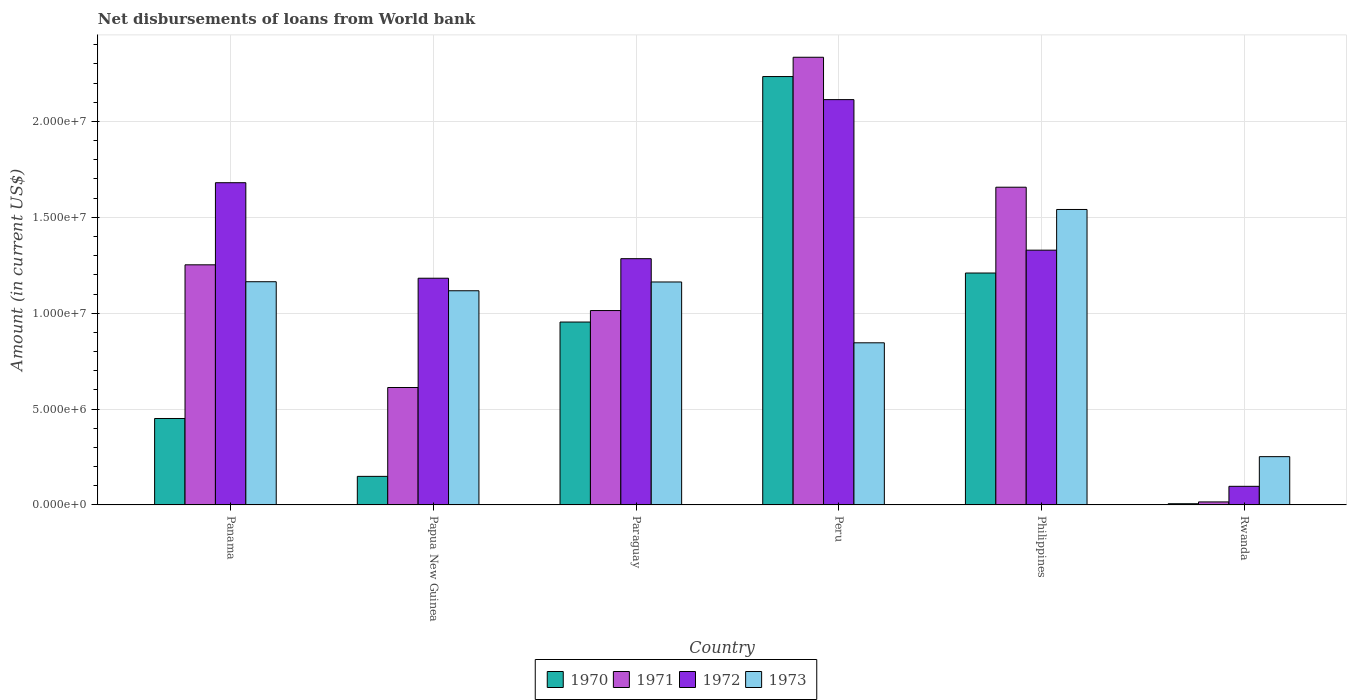How many bars are there on the 4th tick from the left?
Your response must be concise. 4. How many bars are there on the 5th tick from the right?
Give a very brief answer. 4. In how many cases, is the number of bars for a given country not equal to the number of legend labels?
Your response must be concise. 0. What is the amount of loan disbursed from World Bank in 1970 in Peru?
Offer a terse response. 2.23e+07. Across all countries, what is the maximum amount of loan disbursed from World Bank in 1973?
Offer a very short reply. 1.54e+07. Across all countries, what is the minimum amount of loan disbursed from World Bank in 1971?
Provide a succinct answer. 1.57e+05. In which country was the amount of loan disbursed from World Bank in 1970 minimum?
Keep it short and to the point. Rwanda. What is the total amount of loan disbursed from World Bank in 1970 in the graph?
Your answer should be very brief. 5.00e+07. What is the difference between the amount of loan disbursed from World Bank in 1970 in Papua New Guinea and that in Rwanda?
Your response must be concise. 1.43e+06. What is the difference between the amount of loan disbursed from World Bank in 1973 in Rwanda and the amount of loan disbursed from World Bank in 1971 in Peru?
Give a very brief answer. -2.08e+07. What is the average amount of loan disbursed from World Bank in 1972 per country?
Make the answer very short. 1.28e+07. What is the difference between the amount of loan disbursed from World Bank of/in 1973 and amount of loan disbursed from World Bank of/in 1970 in Philippines?
Make the answer very short. 3.31e+06. In how many countries, is the amount of loan disbursed from World Bank in 1970 greater than 12000000 US$?
Your answer should be compact. 2. What is the ratio of the amount of loan disbursed from World Bank in 1973 in Panama to that in Paraguay?
Your answer should be very brief. 1. Is the amount of loan disbursed from World Bank in 1972 in Panama less than that in Rwanda?
Provide a short and direct response. No. What is the difference between the highest and the second highest amount of loan disbursed from World Bank in 1973?
Offer a terse response. 3.78e+06. What is the difference between the highest and the lowest amount of loan disbursed from World Bank in 1972?
Make the answer very short. 2.02e+07. In how many countries, is the amount of loan disbursed from World Bank in 1970 greater than the average amount of loan disbursed from World Bank in 1970 taken over all countries?
Keep it short and to the point. 3. Is it the case that in every country, the sum of the amount of loan disbursed from World Bank in 1973 and amount of loan disbursed from World Bank in 1970 is greater than the sum of amount of loan disbursed from World Bank in 1971 and amount of loan disbursed from World Bank in 1972?
Offer a very short reply. Yes. What does the 1st bar from the left in Philippines represents?
Ensure brevity in your answer.  1970. What does the 2nd bar from the right in Rwanda represents?
Give a very brief answer. 1972. Is it the case that in every country, the sum of the amount of loan disbursed from World Bank in 1972 and amount of loan disbursed from World Bank in 1971 is greater than the amount of loan disbursed from World Bank in 1970?
Give a very brief answer. Yes. How many bars are there?
Your answer should be very brief. 24. Are all the bars in the graph horizontal?
Give a very brief answer. No. How many countries are there in the graph?
Your answer should be very brief. 6. What is the difference between two consecutive major ticks on the Y-axis?
Provide a succinct answer. 5.00e+06. Are the values on the major ticks of Y-axis written in scientific E-notation?
Offer a very short reply. Yes. Does the graph contain grids?
Give a very brief answer. Yes. Where does the legend appear in the graph?
Ensure brevity in your answer.  Bottom center. What is the title of the graph?
Make the answer very short. Net disbursements of loans from World bank. What is the Amount (in current US$) of 1970 in Panama?
Offer a terse response. 4.51e+06. What is the Amount (in current US$) in 1971 in Panama?
Provide a succinct answer. 1.25e+07. What is the Amount (in current US$) in 1972 in Panama?
Make the answer very short. 1.68e+07. What is the Amount (in current US$) in 1973 in Panama?
Offer a very short reply. 1.16e+07. What is the Amount (in current US$) in 1970 in Papua New Guinea?
Provide a short and direct response. 1.49e+06. What is the Amount (in current US$) of 1971 in Papua New Guinea?
Make the answer very short. 6.12e+06. What is the Amount (in current US$) in 1972 in Papua New Guinea?
Offer a terse response. 1.18e+07. What is the Amount (in current US$) of 1973 in Papua New Guinea?
Provide a succinct answer. 1.12e+07. What is the Amount (in current US$) of 1970 in Paraguay?
Ensure brevity in your answer.  9.54e+06. What is the Amount (in current US$) in 1971 in Paraguay?
Your answer should be compact. 1.01e+07. What is the Amount (in current US$) of 1972 in Paraguay?
Provide a short and direct response. 1.28e+07. What is the Amount (in current US$) in 1973 in Paraguay?
Your response must be concise. 1.16e+07. What is the Amount (in current US$) in 1970 in Peru?
Make the answer very short. 2.23e+07. What is the Amount (in current US$) of 1971 in Peru?
Give a very brief answer. 2.33e+07. What is the Amount (in current US$) in 1972 in Peru?
Ensure brevity in your answer.  2.11e+07. What is the Amount (in current US$) of 1973 in Peru?
Keep it short and to the point. 8.46e+06. What is the Amount (in current US$) of 1970 in Philippines?
Your answer should be very brief. 1.21e+07. What is the Amount (in current US$) in 1971 in Philippines?
Your answer should be compact. 1.66e+07. What is the Amount (in current US$) in 1972 in Philippines?
Provide a short and direct response. 1.33e+07. What is the Amount (in current US$) of 1973 in Philippines?
Your response must be concise. 1.54e+07. What is the Amount (in current US$) of 1970 in Rwanda?
Offer a terse response. 6.30e+04. What is the Amount (in current US$) of 1971 in Rwanda?
Provide a short and direct response. 1.57e+05. What is the Amount (in current US$) of 1972 in Rwanda?
Provide a succinct answer. 9.71e+05. What is the Amount (in current US$) in 1973 in Rwanda?
Ensure brevity in your answer.  2.52e+06. Across all countries, what is the maximum Amount (in current US$) of 1970?
Provide a succinct answer. 2.23e+07. Across all countries, what is the maximum Amount (in current US$) in 1971?
Your answer should be compact. 2.33e+07. Across all countries, what is the maximum Amount (in current US$) of 1972?
Make the answer very short. 2.11e+07. Across all countries, what is the maximum Amount (in current US$) in 1973?
Keep it short and to the point. 1.54e+07. Across all countries, what is the minimum Amount (in current US$) in 1970?
Give a very brief answer. 6.30e+04. Across all countries, what is the minimum Amount (in current US$) in 1971?
Provide a short and direct response. 1.57e+05. Across all countries, what is the minimum Amount (in current US$) in 1972?
Give a very brief answer. 9.71e+05. Across all countries, what is the minimum Amount (in current US$) of 1973?
Provide a succinct answer. 2.52e+06. What is the total Amount (in current US$) in 1970 in the graph?
Provide a short and direct response. 5.00e+07. What is the total Amount (in current US$) of 1971 in the graph?
Your answer should be compact. 6.89e+07. What is the total Amount (in current US$) of 1972 in the graph?
Provide a short and direct response. 7.69e+07. What is the total Amount (in current US$) of 1973 in the graph?
Keep it short and to the point. 6.08e+07. What is the difference between the Amount (in current US$) of 1970 in Panama and that in Papua New Guinea?
Offer a terse response. 3.02e+06. What is the difference between the Amount (in current US$) of 1971 in Panama and that in Papua New Guinea?
Keep it short and to the point. 6.40e+06. What is the difference between the Amount (in current US$) in 1972 in Panama and that in Papua New Guinea?
Your response must be concise. 4.98e+06. What is the difference between the Amount (in current US$) in 1973 in Panama and that in Papua New Guinea?
Provide a succinct answer. 4.71e+05. What is the difference between the Amount (in current US$) of 1970 in Panama and that in Paraguay?
Your response must be concise. -5.03e+06. What is the difference between the Amount (in current US$) in 1971 in Panama and that in Paraguay?
Offer a very short reply. 2.38e+06. What is the difference between the Amount (in current US$) of 1972 in Panama and that in Paraguay?
Offer a terse response. 3.96e+06. What is the difference between the Amount (in current US$) in 1973 in Panama and that in Paraguay?
Give a very brief answer. 1.30e+04. What is the difference between the Amount (in current US$) of 1970 in Panama and that in Peru?
Give a very brief answer. -1.78e+07. What is the difference between the Amount (in current US$) of 1971 in Panama and that in Peru?
Ensure brevity in your answer.  -1.08e+07. What is the difference between the Amount (in current US$) in 1972 in Panama and that in Peru?
Your answer should be compact. -4.33e+06. What is the difference between the Amount (in current US$) in 1973 in Panama and that in Peru?
Your response must be concise. 3.18e+06. What is the difference between the Amount (in current US$) of 1970 in Panama and that in Philippines?
Offer a very short reply. -7.59e+06. What is the difference between the Amount (in current US$) in 1971 in Panama and that in Philippines?
Keep it short and to the point. -4.05e+06. What is the difference between the Amount (in current US$) in 1972 in Panama and that in Philippines?
Give a very brief answer. 3.52e+06. What is the difference between the Amount (in current US$) of 1973 in Panama and that in Philippines?
Keep it short and to the point. -3.77e+06. What is the difference between the Amount (in current US$) in 1970 in Panama and that in Rwanda?
Ensure brevity in your answer.  4.44e+06. What is the difference between the Amount (in current US$) of 1971 in Panama and that in Rwanda?
Ensure brevity in your answer.  1.24e+07. What is the difference between the Amount (in current US$) of 1972 in Panama and that in Rwanda?
Ensure brevity in your answer.  1.58e+07. What is the difference between the Amount (in current US$) in 1973 in Panama and that in Rwanda?
Keep it short and to the point. 9.12e+06. What is the difference between the Amount (in current US$) in 1970 in Papua New Guinea and that in Paraguay?
Keep it short and to the point. -8.05e+06. What is the difference between the Amount (in current US$) of 1971 in Papua New Guinea and that in Paraguay?
Offer a very short reply. -4.01e+06. What is the difference between the Amount (in current US$) of 1972 in Papua New Guinea and that in Paraguay?
Your response must be concise. -1.02e+06. What is the difference between the Amount (in current US$) of 1973 in Papua New Guinea and that in Paraguay?
Your response must be concise. -4.58e+05. What is the difference between the Amount (in current US$) in 1970 in Papua New Guinea and that in Peru?
Your answer should be compact. -2.08e+07. What is the difference between the Amount (in current US$) in 1971 in Papua New Guinea and that in Peru?
Offer a very short reply. -1.72e+07. What is the difference between the Amount (in current US$) in 1972 in Papua New Guinea and that in Peru?
Provide a succinct answer. -9.31e+06. What is the difference between the Amount (in current US$) of 1973 in Papua New Guinea and that in Peru?
Offer a terse response. 2.71e+06. What is the difference between the Amount (in current US$) in 1970 in Papua New Guinea and that in Philippines?
Provide a short and direct response. -1.06e+07. What is the difference between the Amount (in current US$) in 1971 in Papua New Guinea and that in Philippines?
Make the answer very short. -1.04e+07. What is the difference between the Amount (in current US$) of 1972 in Papua New Guinea and that in Philippines?
Keep it short and to the point. -1.46e+06. What is the difference between the Amount (in current US$) in 1973 in Papua New Guinea and that in Philippines?
Your answer should be very brief. -4.24e+06. What is the difference between the Amount (in current US$) in 1970 in Papua New Guinea and that in Rwanda?
Provide a short and direct response. 1.43e+06. What is the difference between the Amount (in current US$) in 1971 in Papua New Guinea and that in Rwanda?
Offer a very short reply. 5.97e+06. What is the difference between the Amount (in current US$) of 1972 in Papua New Guinea and that in Rwanda?
Keep it short and to the point. 1.09e+07. What is the difference between the Amount (in current US$) in 1973 in Papua New Guinea and that in Rwanda?
Give a very brief answer. 8.65e+06. What is the difference between the Amount (in current US$) in 1970 in Paraguay and that in Peru?
Provide a succinct answer. -1.28e+07. What is the difference between the Amount (in current US$) in 1971 in Paraguay and that in Peru?
Provide a succinct answer. -1.32e+07. What is the difference between the Amount (in current US$) of 1972 in Paraguay and that in Peru?
Offer a very short reply. -8.30e+06. What is the difference between the Amount (in current US$) in 1973 in Paraguay and that in Peru?
Your answer should be compact. 3.17e+06. What is the difference between the Amount (in current US$) of 1970 in Paraguay and that in Philippines?
Your response must be concise. -2.56e+06. What is the difference between the Amount (in current US$) of 1971 in Paraguay and that in Philippines?
Ensure brevity in your answer.  -6.43e+06. What is the difference between the Amount (in current US$) of 1972 in Paraguay and that in Philippines?
Your response must be concise. -4.44e+05. What is the difference between the Amount (in current US$) of 1973 in Paraguay and that in Philippines?
Offer a very short reply. -3.78e+06. What is the difference between the Amount (in current US$) of 1970 in Paraguay and that in Rwanda?
Provide a succinct answer. 9.48e+06. What is the difference between the Amount (in current US$) of 1971 in Paraguay and that in Rwanda?
Make the answer very short. 9.98e+06. What is the difference between the Amount (in current US$) of 1972 in Paraguay and that in Rwanda?
Ensure brevity in your answer.  1.19e+07. What is the difference between the Amount (in current US$) in 1973 in Paraguay and that in Rwanda?
Offer a terse response. 9.11e+06. What is the difference between the Amount (in current US$) of 1970 in Peru and that in Philippines?
Your answer should be very brief. 1.02e+07. What is the difference between the Amount (in current US$) of 1971 in Peru and that in Philippines?
Give a very brief answer. 6.78e+06. What is the difference between the Amount (in current US$) in 1972 in Peru and that in Philippines?
Give a very brief answer. 7.85e+06. What is the difference between the Amount (in current US$) in 1973 in Peru and that in Philippines?
Offer a very short reply. -6.95e+06. What is the difference between the Amount (in current US$) of 1970 in Peru and that in Rwanda?
Offer a terse response. 2.23e+07. What is the difference between the Amount (in current US$) of 1971 in Peru and that in Rwanda?
Give a very brief answer. 2.32e+07. What is the difference between the Amount (in current US$) in 1972 in Peru and that in Rwanda?
Make the answer very short. 2.02e+07. What is the difference between the Amount (in current US$) of 1973 in Peru and that in Rwanda?
Ensure brevity in your answer.  5.94e+06. What is the difference between the Amount (in current US$) in 1970 in Philippines and that in Rwanda?
Ensure brevity in your answer.  1.20e+07. What is the difference between the Amount (in current US$) in 1971 in Philippines and that in Rwanda?
Offer a terse response. 1.64e+07. What is the difference between the Amount (in current US$) of 1972 in Philippines and that in Rwanda?
Your answer should be very brief. 1.23e+07. What is the difference between the Amount (in current US$) of 1973 in Philippines and that in Rwanda?
Ensure brevity in your answer.  1.29e+07. What is the difference between the Amount (in current US$) of 1970 in Panama and the Amount (in current US$) of 1971 in Papua New Guinea?
Offer a very short reply. -1.62e+06. What is the difference between the Amount (in current US$) in 1970 in Panama and the Amount (in current US$) in 1972 in Papua New Guinea?
Your response must be concise. -7.32e+06. What is the difference between the Amount (in current US$) in 1970 in Panama and the Amount (in current US$) in 1973 in Papua New Guinea?
Offer a terse response. -6.66e+06. What is the difference between the Amount (in current US$) in 1971 in Panama and the Amount (in current US$) in 1972 in Papua New Guinea?
Provide a short and direct response. 6.99e+05. What is the difference between the Amount (in current US$) of 1971 in Panama and the Amount (in current US$) of 1973 in Papua New Guinea?
Your response must be concise. 1.35e+06. What is the difference between the Amount (in current US$) in 1972 in Panama and the Amount (in current US$) in 1973 in Papua New Guinea?
Offer a very short reply. 5.64e+06. What is the difference between the Amount (in current US$) of 1970 in Panama and the Amount (in current US$) of 1971 in Paraguay?
Your response must be concise. -5.63e+06. What is the difference between the Amount (in current US$) in 1970 in Panama and the Amount (in current US$) in 1972 in Paraguay?
Your answer should be very brief. -8.33e+06. What is the difference between the Amount (in current US$) of 1970 in Panama and the Amount (in current US$) of 1973 in Paraguay?
Offer a terse response. -7.12e+06. What is the difference between the Amount (in current US$) in 1971 in Panama and the Amount (in current US$) in 1972 in Paraguay?
Ensure brevity in your answer.  -3.20e+05. What is the difference between the Amount (in current US$) of 1971 in Panama and the Amount (in current US$) of 1973 in Paraguay?
Give a very brief answer. 8.95e+05. What is the difference between the Amount (in current US$) in 1972 in Panama and the Amount (in current US$) in 1973 in Paraguay?
Give a very brief answer. 5.18e+06. What is the difference between the Amount (in current US$) of 1970 in Panama and the Amount (in current US$) of 1971 in Peru?
Provide a succinct answer. -1.88e+07. What is the difference between the Amount (in current US$) of 1970 in Panama and the Amount (in current US$) of 1972 in Peru?
Your answer should be compact. -1.66e+07. What is the difference between the Amount (in current US$) of 1970 in Panama and the Amount (in current US$) of 1973 in Peru?
Keep it short and to the point. -3.95e+06. What is the difference between the Amount (in current US$) of 1971 in Panama and the Amount (in current US$) of 1972 in Peru?
Your response must be concise. -8.62e+06. What is the difference between the Amount (in current US$) of 1971 in Panama and the Amount (in current US$) of 1973 in Peru?
Offer a very short reply. 4.07e+06. What is the difference between the Amount (in current US$) in 1972 in Panama and the Amount (in current US$) in 1973 in Peru?
Make the answer very short. 8.35e+06. What is the difference between the Amount (in current US$) of 1970 in Panama and the Amount (in current US$) of 1971 in Philippines?
Offer a terse response. -1.21e+07. What is the difference between the Amount (in current US$) in 1970 in Panama and the Amount (in current US$) in 1972 in Philippines?
Ensure brevity in your answer.  -8.78e+06. What is the difference between the Amount (in current US$) of 1970 in Panama and the Amount (in current US$) of 1973 in Philippines?
Your response must be concise. -1.09e+07. What is the difference between the Amount (in current US$) of 1971 in Panama and the Amount (in current US$) of 1972 in Philippines?
Your response must be concise. -7.64e+05. What is the difference between the Amount (in current US$) of 1971 in Panama and the Amount (in current US$) of 1973 in Philippines?
Your answer should be compact. -2.89e+06. What is the difference between the Amount (in current US$) of 1972 in Panama and the Amount (in current US$) of 1973 in Philippines?
Your answer should be compact. 1.40e+06. What is the difference between the Amount (in current US$) of 1970 in Panama and the Amount (in current US$) of 1971 in Rwanda?
Offer a terse response. 4.35e+06. What is the difference between the Amount (in current US$) of 1970 in Panama and the Amount (in current US$) of 1972 in Rwanda?
Your answer should be very brief. 3.54e+06. What is the difference between the Amount (in current US$) of 1970 in Panama and the Amount (in current US$) of 1973 in Rwanda?
Your answer should be compact. 1.99e+06. What is the difference between the Amount (in current US$) in 1971 in Panama and the Amount (in current US$) in 1972 in Rwanda?
Offer a terse response. 1.16e+07. What is the difference between the Amount (in current US$) of 1971 in Panama and the Amount (in current US$) of 1973 in Rwanda?
Give a very brief answer. 1.00e+07. What is the difference between the Amount (in current US$) of 1972 in Panama and the Amount (in current US$) of 1973 in Rwanda?
Offer a terse response. 1.43e+07. What is the difference between the Amount (in current US$) in 1970 in Papua New Guinea and the Amount (in current US$) in 1971 in Paraguay?
Keep it short and to the point. -8.65e+06. What is the difference between the Amount (in current US$) in 1970 in Papua New Guinea and the Amount (in current US$) in 1972 in Paraguay?
Make the answer very short. -1.14e+07. What is the difference between the Amount (in current US$) of 1970 in Papua New Guinea and the Amount (in current US$) of 1973 in Paraguay?
Your response must be concise. -1.01e+07. What is the difference between the Amount (in current US$) of 1971 in Papua New Guinea and the Amount (in current US$) of 1972 in Paraguay?
Ensure brevity in your answer.  -6.72e+06. What is the difference between the Amount (in current US$) of 1971 in Papua New Guinea and the Amount (in current US$) of 1973 in Paraguay?
Offer a terse response. -5.50e+06. What is the difference between the Amount (in current US$) of 1972 in Papua New Guinea and the Amount (in current US$) of 1973 in Paraguay?
Ensure brevity in your answer.  1.96e+05. What is the difference between the Amount (in current US$) in 1970 in Papua New Guinea and the Amount (in current US$) in 1971 in Peru?
Offer a terse response. -2.19e+07. What is the difference between the Amount (in current US$) of 1970 in Papua New Guinea and the Amount (in current US$) of 1972 in Peru?
Provide a short and direct response. -1.96e+07. What is the difference between the Amount (in current US$) in 1970 in Papua New Guinea and the Amount (in current US$) in 1973 in Peru?
Provide a succinct answer. -6.96e+06. What is the difference between the Amount (in current US$) in 1971 in Papua New Guinea and the Amount (in current US$) in 1972 in Peru?
Provide a succinct answer. -1.50e+07. What is the difference between the Amount (in current US$) of 1971 in Papua New Guinea and the Amount (in current US$) of 1973 in Peru?
Make the answer very short. -2.33e+06. What is the difference between the Amount (in current US$) in 1972 in Papua New Guinea and the Amount (in current US$) in 1973 in Peru?
Your response must be concise. 3.37e+06. What is the difference between the Amount (in current US$) in 1970 in Papua New Guinea and the Amount (in current US$) in 1971 in Philippines?
Keep it short and to the point. -1.51e+07. What is the difference between the Amount (in current US$) in 1970 in Papua New Guinea and the Amount (in current US$) in 1972 in Philippines?
Offer a terse response. -1.18e+07. What is the difference between the Amount (in current US$) of 1970 in Papua New Guinea and the Amount (in current US$) of 1973 in Philippines?
Keep it short and to the point. -1.39e+07. What is the difference between the Amount (in current US$) in 1971 in Papua New Guinea and the Amount (in current US$) in 1972 in Philippines?
Make the answer very short. -7.16e+06. What is the difference between the Amount (in current US$) in 1971 in Papua New Guinea and the Amount (in current US$) in 1973 in Philippines?
Your answer should be very brief. -9.28e+06. What is the difference between the Amount (in current US$) of 1972 in Papua New Guinea and the Amount (in current US$) of 1973 in Philippines?
Your answer should be very brief. -3.58e+06. What is the difference between the Amount (in current US$) of 1970 in Papua New Guinea and the Amount (in current US$) of 1971 in Rwanda?
Keep it short and to the point. 1.33e+06. What is the difference between the Amount (in current US$) in 1970 in Papua New Guinea and the Amount (in current US$) in 1972 in Rwanda?
Offer a terse response. 5.19e+05. What is the difference between the Amount (in current US$) of 1970 in Papua New Guinea and the Amount (in current US$) of 1973 in Rwanda?
Provide a succinct answer. -1.03e+06. What is the difference between the Amount (in current US$) of 1971 in Papua New Guinea and the Amount (in current US$) of 1972 in Rwanda?
Offer a very short reply. 5.15e+06. What is the difference between the Amount (in current US$) of 1971 in Papua New Guinea and the Amount (in current US$) of 1973 in Rwanda?
Your answer should be very brief. 3.61e+06. What is the difference between the Amount (in current US$) in 1972 in Papua New Guinea and the Amount (in current US$) in 1973 in Rwanda?
Make the answer very short. 9.30e+06. What is the difference between the Amount (in current US$) in 1970 in Paraguay and the Amount (in current US$) in 1971 in Peru?
Provide a succinct answer. -1.38e+07. What is the difference between the Amount (in current US$) of 1970 in Paraguay and the Amount (in current US$) of 1972 in Peru?
Offer a terse response. -1.16e+07. What is the difference between the Amount (in current US$) of 1970 in Paraguay and the Amount (in current US$) of 1973 in Peru?
Ensure brevity in your answer.  1.08e+06. What is the difference between the Amount (in current US$) in 1971 in Paraguay and the Amount (in current US$) in 1972 in Peru?
Provide a short and direct response. -1.10e+07. What is the difference between the Amount (in current US$) in 1971 in Paraguay and the Amount (in current US$) in 1973 in Peru?
Your answer should be compact. 1.68e+06. What is the difference between the Amount (in current US$) in 1972 in Paraguay and the Amount (in current US$) in 1973 in Peru?
Your response must be concise. 4.39e+06. What is the difference between the Amount (in current US$) of 1970 in Paraguay and the Amount (in current US$) of 1971 in Philippines?
Your response must be concise. -7.03e+06. What is the difference between the Amount (in current US$) in 1970 in Paraguay and the Amount (in current US$) in 1972 in Philippines?
Ensure brevity in your answer.  -3.75e+06. What is the difference between the Amount (in current US$) in 1970 in Paraguay and the Amount (in current US$) in 1973 in Philippines?
Offer a very short reply. -5.87e+06. What is the difference between the Amount (in current US$) in 1971 in Paraguay and the Amount (in current US$) in 1972 in Philippines?
Your answer should be compact. -3.15e+06. What is the difference between the Amount (in current US$) of 1971 in Paraguay and the Amount (in current US$) of 1973 in Philippines?
Provide a succinct answer. -5.27e+06. What is the difference between the Amount (in current US$) in 1972 in Paraguay and the Amount (in current US$) in 1973 in Philippines?
Offer a very short reply. -2.57e+06. What is the difference between the Amount (in current US$) in 1970 in Paraguay and the Amount (in current US$) in 1971 in Rwanda?
Your answer should be very brief. 9.38e+06. What is the difference between the Amount (in current US$) of 1970 in Paraguay and the Amount (in current US$) of 1972 in Rwanda?
Offer a terse response. 8.57e+06. What is the difference between the Amount (in current US$) of 1970 in Paraguay and the Amount (in current US$) of 1973 in Rwanda?
Offer a very short reply. 7.02e+06. What is the difference between the Amount (in current US$) of 1971 in Paraguay and the Amount (in current US$) of 1972 in Rwanda?
Your answer should be very brief. 9.17e+06. What is the difference between the Amount (in current US$) in 1971 in Paraguay and the Amount (in current US$) in 1973 in Rwanda?
Offer a very short reply. 7.62e+06. What is the difference between the Amount (in current US$) in 1972 in Paraguay and the Amount (in current US$) in 1973 in Rwanda?
Your response must be concise. 1.03e+07. What is the difference between the Amount (in current US$) in 1970 in Peru and the Amount (in current US$) in 1971 in Philippines?
Provide a short and direct response. 5.77e+06. What is the difference between the Amount (in current US$) of 1970 in Peru and the Amount (in current US$) of 1972 in Philippines?
Keep it short and to the point. 9.05e+06. What is the difference between the Amount (in current US$) in 1970 in Peru and the Amount (in current US$) in 1973 in Philippines?
Offer a very short reply. 6.93e+06. What is the difference between the Amount (in current US$) of 1971 in Peru and the Amount (in current US$) of 1972 in Philippines?
Offer a terse response. 1.01e+07. What is the difference between the Amount (in current US$) in 1971 in Peru and the Amount (in current US$) in 1973 in Philippines?
Give a very brief answer. 7.94e+06. What is the difference between the Amount (in current US$) in 1972 in Peru and the Amount (in current US$) in 1973 in Philippines?
Your answer should be compact. 5.73e+06. What is the difference between the Amount (in current US$) of 1970 in Peru and the Amount (in current US$) of 1971 in Rwanda?
Keep it short and to the point. 2.22e+07. What is the difference between the Amount (in current US$) in 1970 in Peru and the Amount (in current US$) in 1972 in Rwanda?
Make the answer very short. 2.14e+07. What is the difference between the Amount (in current US$) in 1970 in Peru and the Amount (in current US$) in 1973 in Rwanda?
Make the answer very short. 1.98e+07. What is the difference between the Amount (in current US$) in 1971 in Peru and the Amount (in current US$) in 1972 in Rwanda?
Your response must be concise. 2.24e+07. What is the difference between the Amount (in current US$) in 1971 in Peru and the Amount (in current US$) in 1973 in Rwanda?
Provide a succinct answer. 2.08e+07. What is the difference between the Amount (in current US$) of 1972 in Peru and the Amount (in current US$) of 1973 in Rwanda?
Your response must be concise. 1.86e+07. What is the difference between the Amount (in current US$) in 1970 in Philippines and the Amount (in current US$) in 1971 in Rwanda?
Provide a succinct answer. 1.19e+07. What is the difference between the Amount (in current US$) in 1970 in Philippines and the Amount (in current US$) in 1972 in Rwanda?
Your response must be concise. 1.11e+07. What is the difference between the Amount (in current US$) of 1970 in Philippines and the Amount (in current US$) of 1973 in Rwanda?
Provide a short and direct response. 9.58e+06. What is the difference between the Amount (in current US$) of 1971 in Philippines and the Amount (in current US$) of 1972 in Rwanda?
Your response must be concise. 1.56e+07. What is the difference between the Amount (in current US$) of 1971 in Philippines and the Amount (in current US$) of 1973 in Rwanda?
Ensure brevity in your answer.  1.41e+07. What is the difference between the Amount (in current US$) of 1972 in Philippines and the Amount (in current US$) of 1973 in Rwanda?
Provide a short and direct response. 1.08e+07. What is the average Amount (in current US$) of 1970 per country?
Your response must be concise. 8.34e+06. What is the average Amount (in current US$) in 1971 per country?
Provide a short and direct response. 1.15e+07. What is the average Amount (in current US$) in 1972 per country?
Provide a succinct answer. 1.28e+07. What is the average Amount (in current US$) of 1973 per country?
Your response must be concise. 1.01e+07. What is the difference between the Amount (in current US$) in 1970 and Amount (in current US$) in 1971 in Panama?
Offer a very short reply. -8.01e+06. What is the difference between the Amount (in current US$) of 1970 and Amount (in current US$) of 1972 in Panama?
Make the answer very short. -1.23e+07. What is the difference between the Amount (in current US$) in 1970 and Amount (in current US$) in 1973 in Panama?
Give a very brief answer. -7.13e+06. What is the difference between the Amount (in current US$) in 1971 and Amount (in current US$) in 1972 in Panama?
Offer a very short reply. -4.28e+06. What is the difference between the Amount (in current US$) of 1971 and Amount (in current US$) of 1973 in Panama?
Provide a succinct answer. 8.82e+05. What is the difference between the Amount (in current US$) of 1972 and Amount (in current US$) of 1973 in Panama?
Give a very brief answer. 5.16e+06. What is the difference between the Amount (in current US$) of 1970 and Amount (in current US$) of 1971 in Papua New Guinea?
Ensure brevity in your answer.  -4.63e+06. What is the difference between the Amount (in current US$) in 1970 and Amount (in current US$) in 1972 in Papua New Guinea?
Keep it short and to the point. -1.03e+07. What is the difference between the Amount (in current US$) in 1970 and Amount (in current US$) in 1973 in Papua New Guinea?
Keep it short and to the point. -9.68e+06. What is the difference between the Amount (in current US$) in 1971 and Amount (in current US$) in 1972 in Papua New Guinea?
Make the answer very short. -5.70e+06. What is the difference between the Amount (in current US$) of 1971 and Amount (in current US$) of 1973 in Papua New Guinea?
Provide a succinct answer. -5.04e+06. What is the difference between the Amount (in current US$) of 1972 and Amount (in current US$) of 1973 in Papua New Guinea?
Keep it short and to the point. 6.54e+05. What is the difference between the Amount (in current US$) in 1970 and Amount (in current US$) in 1971 in Paraguay?
Offer a very short reply. -5.99e+05. What is the difference between the Amount (in current US$) in 1970 and Amount (in current US$) in 1972 in Paraguay?
Offer a very short reply. -3.30e+06. What is the difference between the Amount (in current US$) in 1970 and Amount (in current US$) in 1973 in Paraguay?
Your answer should be very brief. -2.09e+06. What is the difference between the Amount (in current US$) of 1971 and Amount (in current US$) of 1972 in Paraguay?
Ensure brevity in your answer.  -2.70e+06. What is the difference between the Amount (in current US$) in 1971 and Amount (in current US$) in 1973 in Paraguay?
Your response must be concise. -1.49e+06. What is the difference between the Amount (in current US$) in 1972 and Amount (in current US$) in 1973 in Paraguay?
Ensure brevity in your answer.  1.22e+06. What is the difference between the Amount (in current US$) in 1970 and Amount (in current US$) in 1971 in Peru?
Your response must be concise. -1.01e+06. What is the difference between the Amount (in current US$) in 1970 and Amount (in current US$) in 1972 in Peru?
Your answer should be very brief. 1.20e+06. What is the difference between the Amount (in current US$) in 1970 and Amount (in current US$) in 1973 in Peru?
Provide a succinct answer. 1.39e+07. What is the difference between the Amount (in current US$) in 1971 and Amount (in current US$) in 1972 in Peru?
Offer a very short reply. 2.21e+06. What is the difference between the Amount (in current US$) of 1971 and Amount (in current US$) of 1973 in Peru?
Make the answer very short. 1.49e+07. What is the difference between the Amount (in current US$) in 1972 and Amount (in current US$) in 1973 in Peru?
Your answer should be compact. 1.27e+07. What is the difference between the Amount (in current US$) of 1970 and Amount (in current US$) of 1971 in Philippines?
Offer a terse response. -4.48e+06. What is the difference between the Amount (in current US$) in 1970 and Amount (in current US$) in 1972 in Philippines?
Provide a succinct answer. -1.19e+06. What is the difference between the Amount (in current US$) in 1970 and Amount (in current US$) in 1973 in Philippines?
Your answer should be compact. -3.31e+06. What is the difference between the Amount (in current US$) in 1971 and Amount (in current US$) in 1972 in Philippines?
Provide a short and direct response. 3.28e+06. What is the difference between the Amount (in current US$) in 1971 and Amount (in current US$) in 1973 in Philippines?
Provide a short and direct response. 1.16e+06. What is the difference between the Amount (in current US$) in 1972 and Amount (in current US$) in 1973 in Philippines?
Offer a very short reply. -2.12e+06. What is the difference between the Amount (in current US$) in 1970 and Amount (in current US$) in 1971 in Rwanda?
Make the answer very short. -9.40e+04. What is the difference between the Amount (in current US$) of 1970 and Amount (in current US$) of 1972 in Rwanda?
Ensure brevity in your answer.  -9.08e+05. What is the difference between the Amount (in current US$) in 1970 and Amount (in current US$) in 1973 in Rwanda?
Provide a short and direct response. -2.46e+06. What is the difference between the Amount (in current US$) in 1971 and Amount (in current US$) in 1972 in Rwanda?
Make the answer very short. -8.14e+05. What is the difference between the Amount (in current US$) in 1971 and Amount (in current US$) in 1973 in Rwanda?
Provide a succinct answer. -2.36e+06. What is the difference between the Amount (in current US$) of 1972 and Amount (in current US$) of 1973 in Rwanda?
Give a very brief answer. -1.55e+06. What is the ratio of the Amount (in current US$) in 1970 in Panama to that in Papua New Guinea?
Keep it short and to the point. 3.03. What is the ratio of the Amount (in current US$) of 1971 in Panama to that in Papua New Guinea?
Provide a short and direct response. 2.04. What is the ratio of the Amount (in current US$) of 1972 in Panama to that in Papua New Guinea?
Give a very brief answer. 1.42. What is the ratio of the Amount (in current US$) of 1973 in Panama to that in Papua New Guinea?
Provide a succinct answer. 1.04. What is the ratio of the Amount (in current US$) of 1970 in Panama to that in Paraguay?
Your response must be concise. 0.47. What is the ratio of the Amount (in current US$) of 1971 in Panama to that in Paraguay?
Provide a succinct answer. 1.24. What is the ratio of the Amount (in current US$) of 1972 in Panama to that in Paraguay?
Your answer should be very brief. 1.31. What is the ratio of the Amount (in current US$) of 1970 in Panama to that in Peru?
Your response must be concise. 0.2. What is the ratio of the Amount (in current US$) of 1971 in Panama to that in Peru?
Offer a very short reply. 0.54. What is the ratio of the Amount (in current US$) of 1972 in Panama to that in Peru?
Make the answer very short. 0.8. What is the ratio of the Amount (in current US$) in 1973 in Panama to that in Peru?
Provide a succinct answer. 1.38. What is the ratio of the Amount (in current US$) of 1970 in Panama to that in Philippines?
Your answer should be compact. 0.37. What is the ratio of the Amount (in current US$) of 1971 in Panama to that in Philippines?
Offer a terse response. 0.76. What is the ratio of the Amount (in current US$) in 1972 in Panama to that in Philippines?
Your answer should be compact. 1.26. What is the ratio of the Amount (in current US$) of 1973 in Panama to that in Philippines?
Your answer should be very brief. 0.76. What is the ratio of the Amount (in current US$) of 1970 in Panama to that in Rwanda?
Ensure brevity in your answer.  71.56. What is the ratio of the Amount (in current US$) of 1971 in Panama to that in Rwanda?
Provide a succinct answer. 79.76. What is the ratio of the Amount (in current US$) of 1972 in Panama to that in Rwanda?
Make the answer very short. 17.31. What is the ratio of the Amount (in current US$) of 1973 in Panama to that in Rwanda?
Your response must be concise. 4.62. What is the ratio of the Amount (in current US$) in 1970 in Papua New Guinea to that in Paraguay?
Your answer should be very brief. 0.16. What is the ratio of the Amount (in current US$) in 1971 in Papua New Guinea to that in Paraguay?
Your answer should be very brief. 0.6. What is the ratio of the Amount (in current US$) of 1972 in Papua New Guinea to that in Paraguay?
Offer a terse response. 0.92. What is the ratio of the Amount (in current US$) of 1973 in Papua New Guinea to that in Paraguay?
Your response must be concise. 0.96. What is the ratio of the Amount (in current US$) of 1970 in Papua New Guinea to that in Peru?
Keep it short and to the point. 0.07. What is the ratio of the Amount (in current US$) in 1971 in Papua New Guinea to that in Peru?
Your answer should be very brief. 0.26. What is the ratio of the Amount (in current US$) in 1972 in Papua New Guinea to that in Peru?
Your answer should be very brief. 0.56. What is the ratio of the Amount (in current US$) of 1973 in Papua New Guinea to that in Peru?
Keep it short and to the point. 1.32. What is the ratio of the Amount (in current US$) of 1970 in Papua New Guinea to that in Philippines?
Offer a very short reply. 0.12. What is the ratio of the Amount (in current US$) of 1971 in Papua New Guinea to that in Philippines?
Ensure brevity in your answer.  0.37. What is the ratio of the Amount (in current US$) in 1972 in Papua New Guinea to that in Philippines?
Ensure brevity in your answer.  0.89. What is the ratio of the Amount (in current US$) in 1973 in Papua New Guinea to that in Philippines?
Offer a very short reply. 0.72. What is the ratio of the Amount (in current US$) of 1970 in Papua New Guinea to that in Rwanda?
Offer a terse response. 23.65. What is the ratio of the Amount (in current US$) of 1971 in Papua New Guinea to that in Rwanda?
Your answer should be very brief. 39.01. What is the ratio of the Amount (in current US$) of 1972 in Papua New Guinea to that in Rwanda?
Give a very brief answer. 12.18. What is the ratio of the Amount (in current US$) in 1973 in Papua New Guinea to that in Rwanda?
Keep it short and to the point. 4.44. What is the ratio of the Amount (in current US$) in 1970 in Paraguay to that in Peru?
Keep it short and to the point. 0.43. What is the ratio of the Amount (in current US$) in 1971 in Paraguay to that in Peru?
Provide a short and direct response. 0.43. What is the ratio of the Amount (in current US$) of 1972 in Paraguay to that in Peru?
Your answer should be very brief. 0.61. What is the ratio of the Amount (in current US$) of 1973 in Paraguay to that in Peru?
Make the answer very short. 1.38. What is the ratio of the Amount (in current US$) of 1970 in Paraguay to that in Philippines?
Offer a very short reply. 0.79. What is the ratio of the Amount (in current US$) of 1971 in Paraguay to that in Philippines?
Your answer should be compact. 0.61. What is the ratio of the Amount (in current US$) of 1972 in Paraguay to that in Philippines?
Provide a succinct answer. 0.97. What is the ratio of the Amount (in current US$) of 1973 in Paraguay to that in Philippines?
Your response must be concise. 0.75. What is the ratio of the Amount (in current US$) of 1970 in Paraguay to that in Rwanda?
Ensure brevity in your answer.  151.4. What is the ratio of the Amount (in current US$) in 1971 in Paraguay to that in Rwanda?
Provide a short and direct response. 64.57. What is the ratio of the Amount (in current US$) of 1972 in Paraguay to that in Rwanda?
Offer a very short reply. 13.23. What is the ratio of the Amount (in current US$) of 1973 in Paraguay to that in Rwanda?
Your answer should be very brief. 4.62. What is the ratio of the Amount (in current US$) in 1970 in Peru to that in Philippines?
Ensure brevity in your answer.  1.85. What is the ratio of the Amount (in current US$) in 1971 in Peru to that in Philippines?
Offer a terse response. 1.41. What is the ratio of the Amount (in current US$) in 1972 in Peru to that in Philippines?
Your answer should be very brief. 1.59. What is the ratio of the Amount (in current US$) of 1973 in Peru to that in Philippines?
Ensure brevity in your answer.  0.55. What is the ratio of the Amount (in current US$) in 1970 in Peru to that in Rwanda?
Your response must be concise. 354.6. What is the ratio of the Amount (in current US$) in 1971 in Peru to that in Rwanda?
Give a very brief answer. 148.7. What is the ratio of the Amount (in current US$) in 1972 in Peru to that in Rwanda?
Provide a short and direct response. 21.77. What is the ratio of the Amount (in current US$) of 1973 in Peru to that in Rwanda?
Offer a very short reply. 3.36. What is the ratio of the Amount (in current US$) of 1970 in Philippines to that in Rwanda?
Ensure brevity in your answer.  191.97. What is the ratio of the Amount (in current US$) in 1971 in Philippines to that in Rwanda?
Give a very brief answer. 105.53. What is the ratio of the Amount (in current US$) in 1972 in Philippines to that in Rwanda?
Keep it short and to the point. 13.68. What is the ratio of the Amount (in current US$) in 1973 in Philippines to that in Rwanda?
Your answer should be compact. 6.12. What is the difference between the highest and the second highest Amount (in current US$) of 1970?
Give a very brief answer. 1.02e+07. What is the difference between the highest and the second highest Amount (in current US$) of 1971?
Ensure brevity in your answer.  6.78e+06. What is the difference between the highest and the second highest Amount (in current US$) in 1972?
Offer a very short reply. 4.33e+06. What is the difference between the highest and the second highest Amount (in current US$) in 1973?
Your answer should be very brief. 3.77e+06. What is the difference between the highest and the lowest Amount (in current US$) in 1970?
Provide a short and direct response. 2.23e+07. What is the difference between the highest and the lowest Amount (in current US$) of 1971?
Provide a succinct answer. 2.32e+07. What is the difference between the highest and the lowest Amount (in current US$) of 1972?
Your answer should be very brief. 2.02e+07. What is the difference between the highest and the lowest Amount (in current US$) of 1973?
Give a very brief answer. 1.29e+07. 